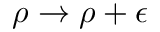<formula> <loc_0><loc_0><loc_500><loc_500>\rho \to \rho + \epsilon</formula> 